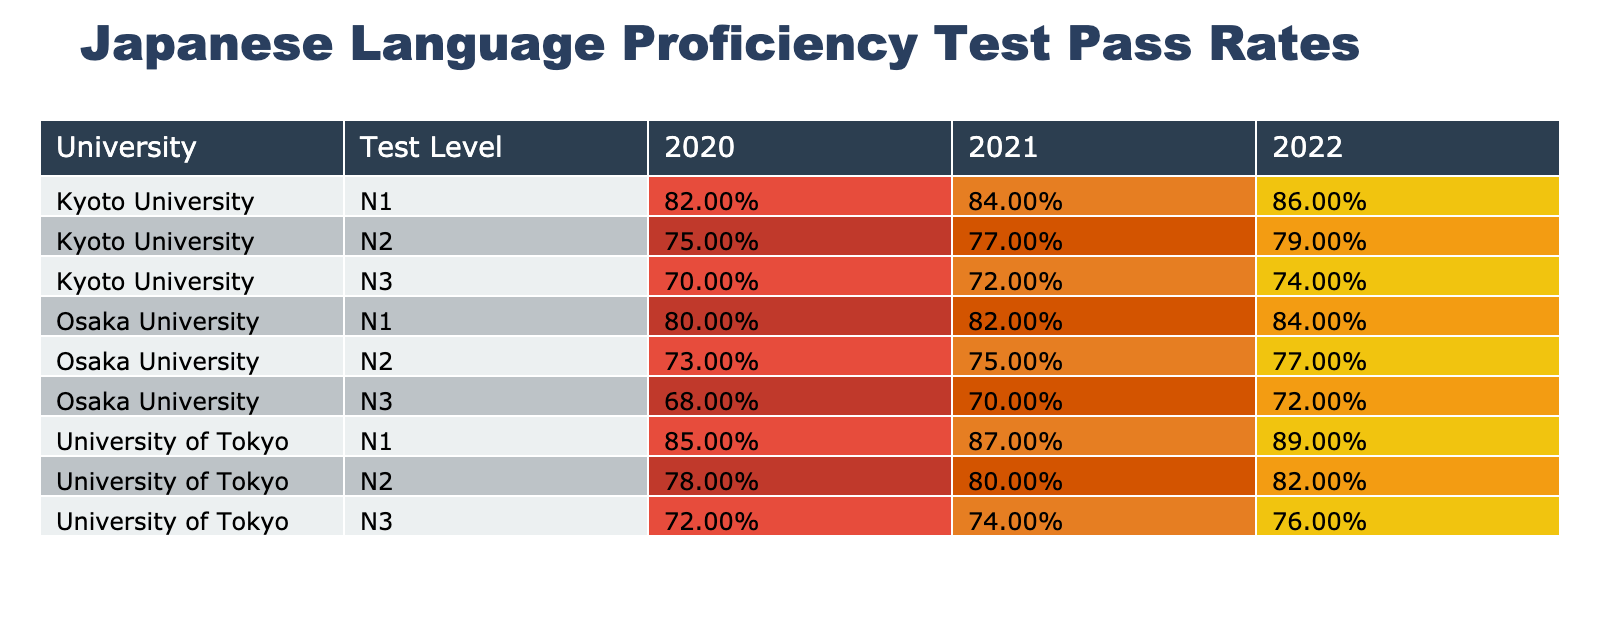What is the pass rate for N3 level at Kyoto University in 2021? In the table, I look for the row corresponding to Kyoto University, N3 level for the year 2021. The pass rate listed in that row is 0.72.
Answer: 0.72 Which university had the highest average score for N1 level in 2022? I need to examine the rows corresponding to N1 level across all universities in 2022. The University of Tokyo has the highest average score of 140, compared to Kyoto University's 135 and Osaka University's 130.
Answer: University of Tokyo What is the difference in pass rates for N2 level between University of Tokyo and Osaka University in 2020? I find the pass rates for N2 level from both universities in 2020. The University of Tokyo has a pass rate of 0.78, and Osaka University has a pass rate of 0.73. The difference is 0.78 - 0.73 = 0.05.
Answer: 0.05 Was the average score for N3 level at Osaka University higher in 2021 than in 2020? I check the average scores for N3 level at Osaka University. In 2021, the score is 103, and in 2020 it is 100. Since 103 is greater than 100, the average score was higher in 2021.
Answer: Yes What was the overall average pass rate for Kyoto University across all levels in 2022? To find the overall average for Kyoto University in 2022, I look at the pass rates for all levels: N1 is 0.86, N2 is 0.79, and N3 is 0.74. The sum is 0.86 + 0.79 + 0.74 = 2.39, and there are 3 levels, so the average is 2.39 / 3 = 0.7967.
Answer: 0.7967 